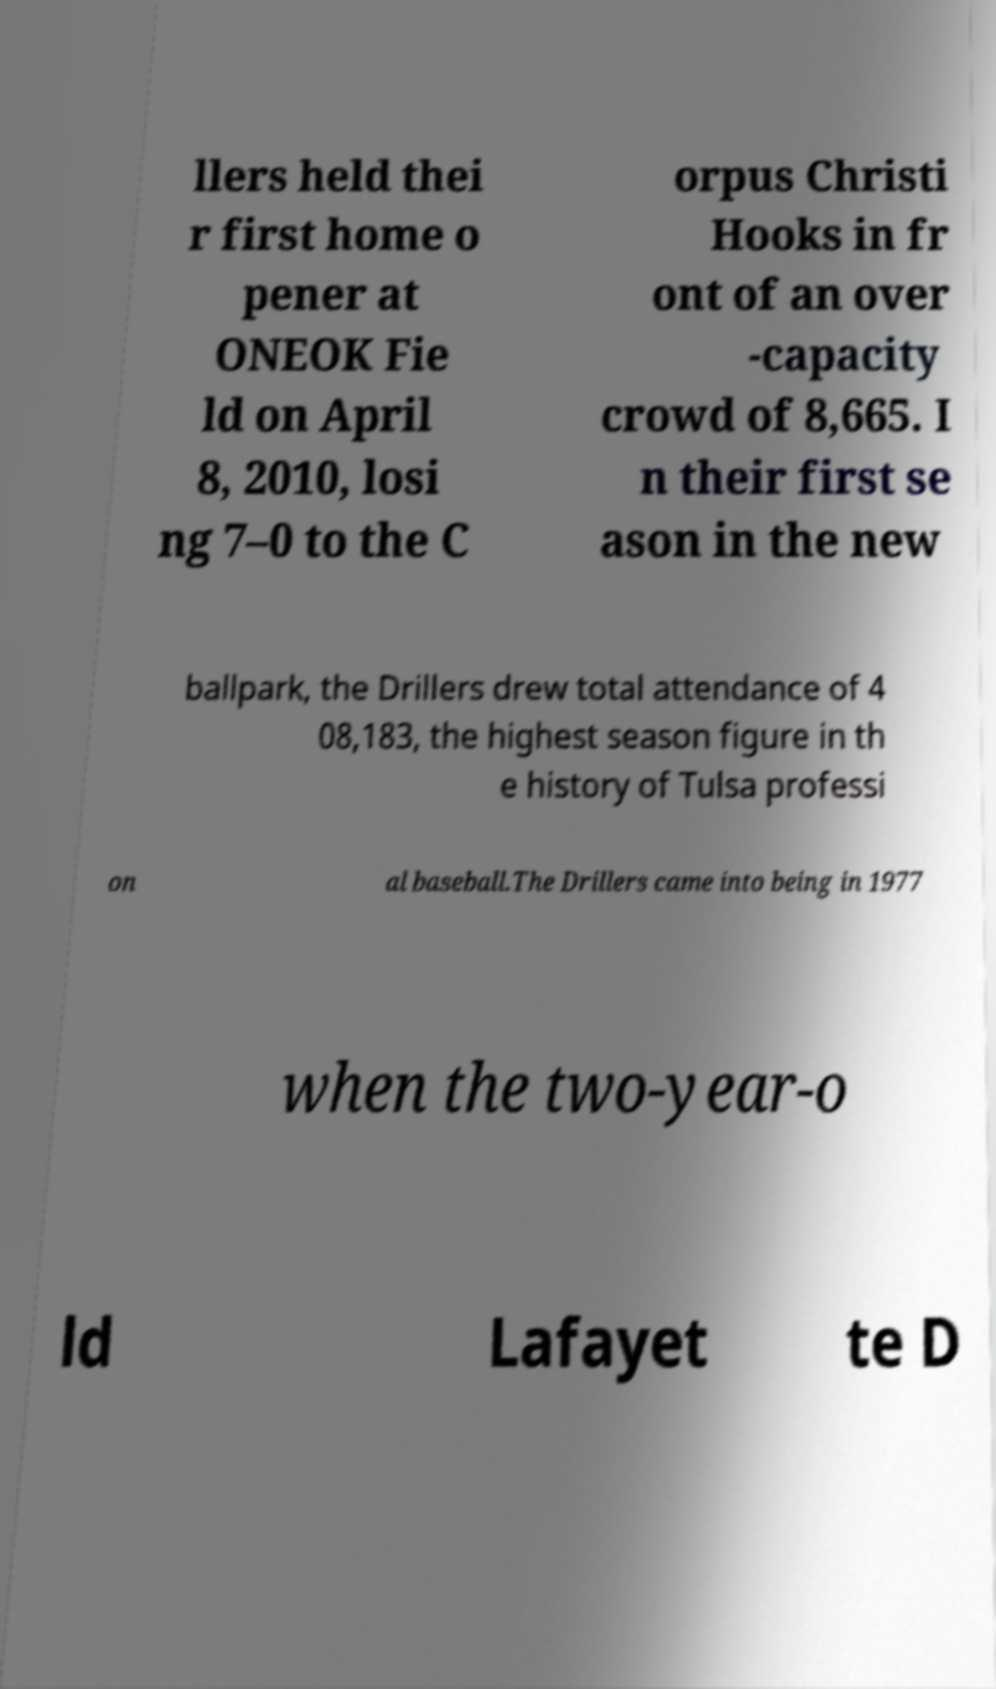Please identify and transcribe the text found in this image. llers held thei r first home o pener at ONEOK Fie ld on April 8, 2010, losi ng 7–0 to the C orpus Christi Hooks in fr ont of an over -capacity crowd of 8,665. I n their first se ason in the new ballpark, the Drillers drew total attendance of 4 08,183, the highest season figure in th e history of Tulsa professi on al baseball.The Drillers came into being in 1977 when the two-year-o ld Lafayet te D 